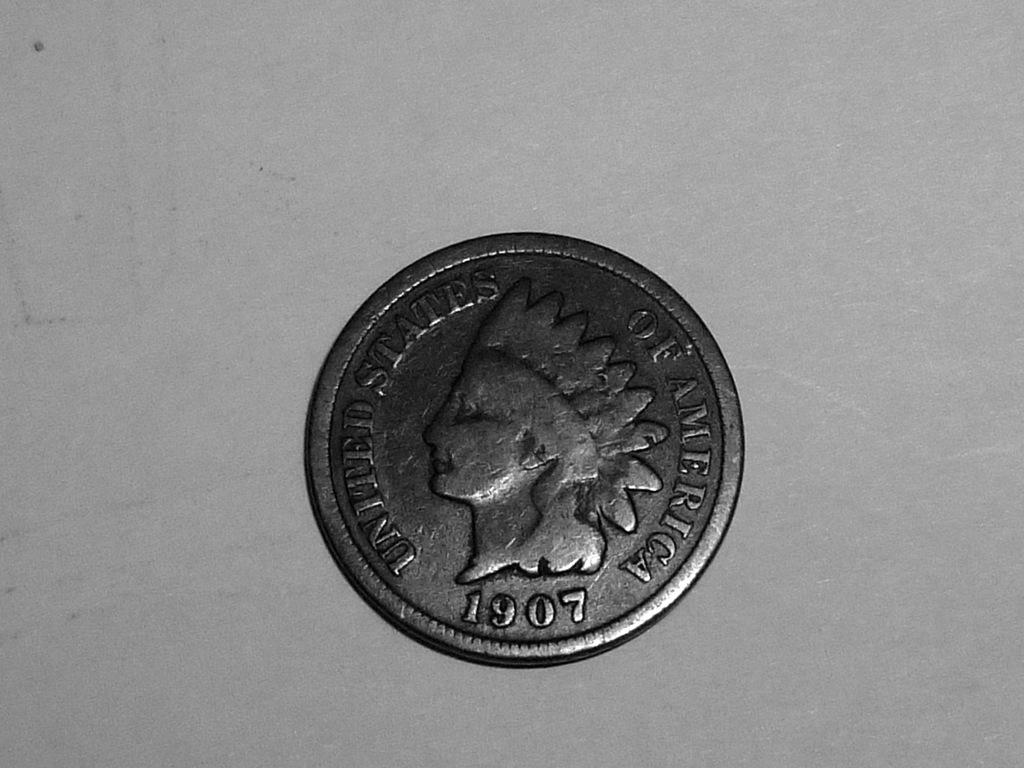What year was the coin produced?
Your answer should be very brief. 1907. What country was this coin made in?
Give a very brief answer. United states. 